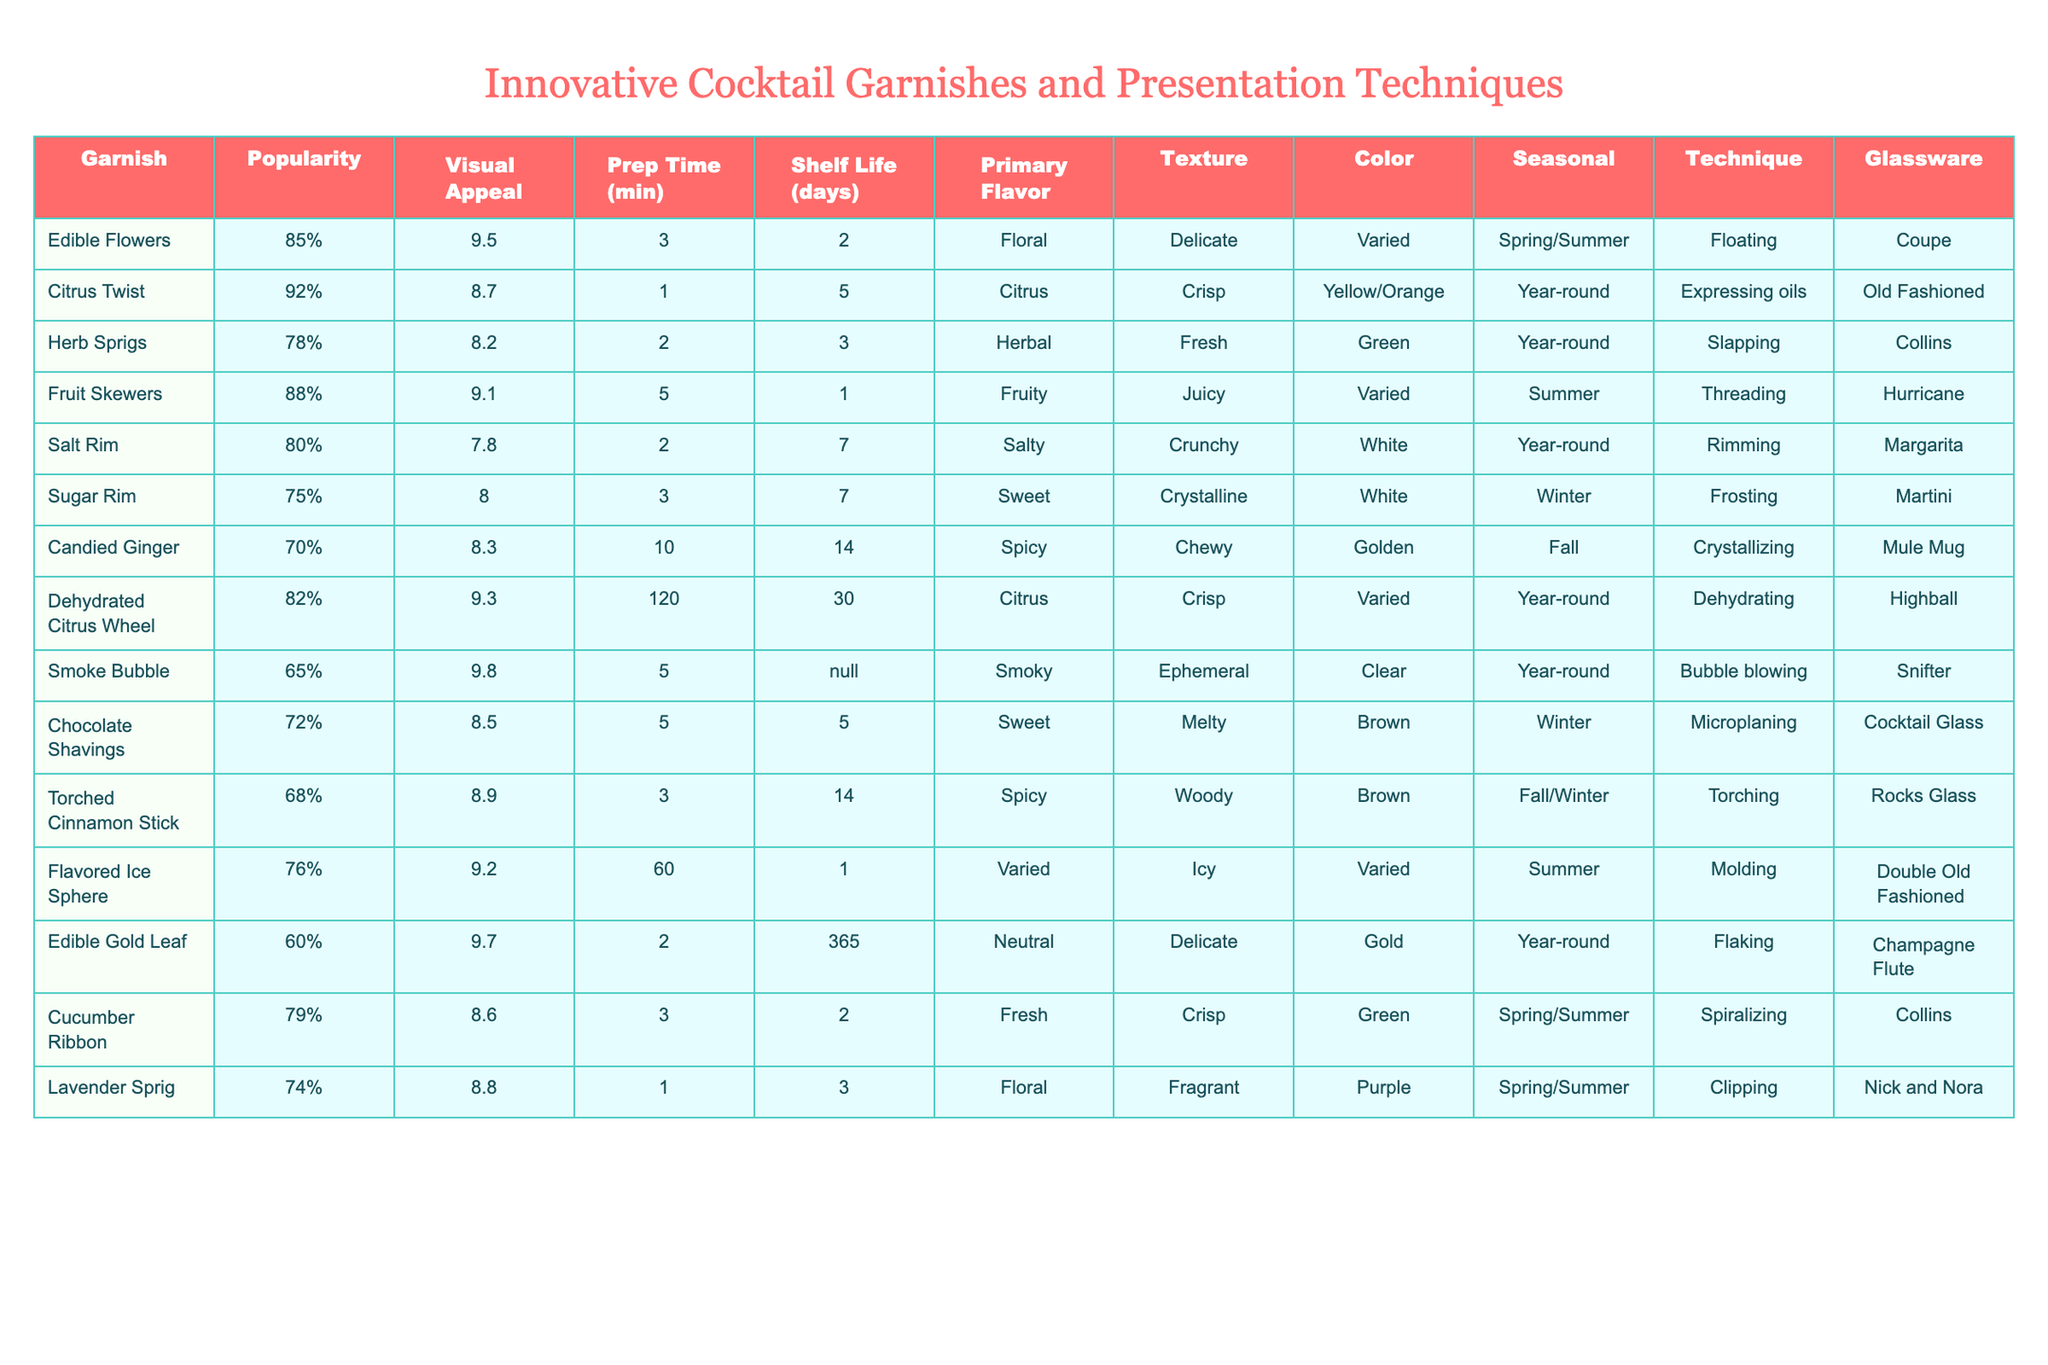What garnish has the highest popularity rating? The table lists the popularity ratings for each garnish. The highest rating is 92% for the Citrus Twist.
Answer: Citrus Twist Which garnish requires the longest preparation time? The table shows that the Candied Ginger requires the longest prep time of 10 minutes.
Answer: Candied Ginger Is the Chocolate Shavings garnish available year-round? The table indicates that Chocolate Shavings are available only in Winter, making the statement false.
Answer: No What is the average visual appeal score of garnishes that have "Floral" as their primary flavor? The table lists two garnishes with "Floral" flavor: Edible Flowers (9.5) and Lavender Sprig (8.8). The average is (9.5 + 8.8) / 2 = 9.15.
Answer: 9.15 Which garnish has the shortest shelf life and what is that shelf life? Reviewing the table, Fruit Skewers have the shortest shelf life of just 1 day.
Answer: 1 day How many garnishes have a "Crisp" texture? The table lists three garnishes with a "Crisp" texture: Citrus Twist, Dehydrated Citrus Wheel, and Cucumber Ribbon, totaling three.
Answer: 3 What color is the Edible Gold Leaf garnish? According to the table, the Edible Gold Leaf is gold in color.
Answer: Gold Which presentation technique is commonly used with garnishes that are green in color? The table shows that both Herb Sprigs and Cucumber Ribbon use slapping and spiralizing techniques, respectively; thus, no single technique is exclusive to all green garnishes.
Answer: None exclusively Is there a garnish that is visually appealing (above 9) and also seasonal for Fall? The table shows that both Torched Cinnamon Stick (8.9) and Candied Ginger (8.3) do not exceed a score of 9. Thus, there are none that fit this category.
Answer: No Determine the total number of garnishes that take 2 minutes or less to prepare. The table shows that Cucumber Ribbon (3), Salt Rim (2), and Citrus Twist (1) as garnishes with prep times of 2 minutes or less. Therefore, there are three in total.
Answer: 3 